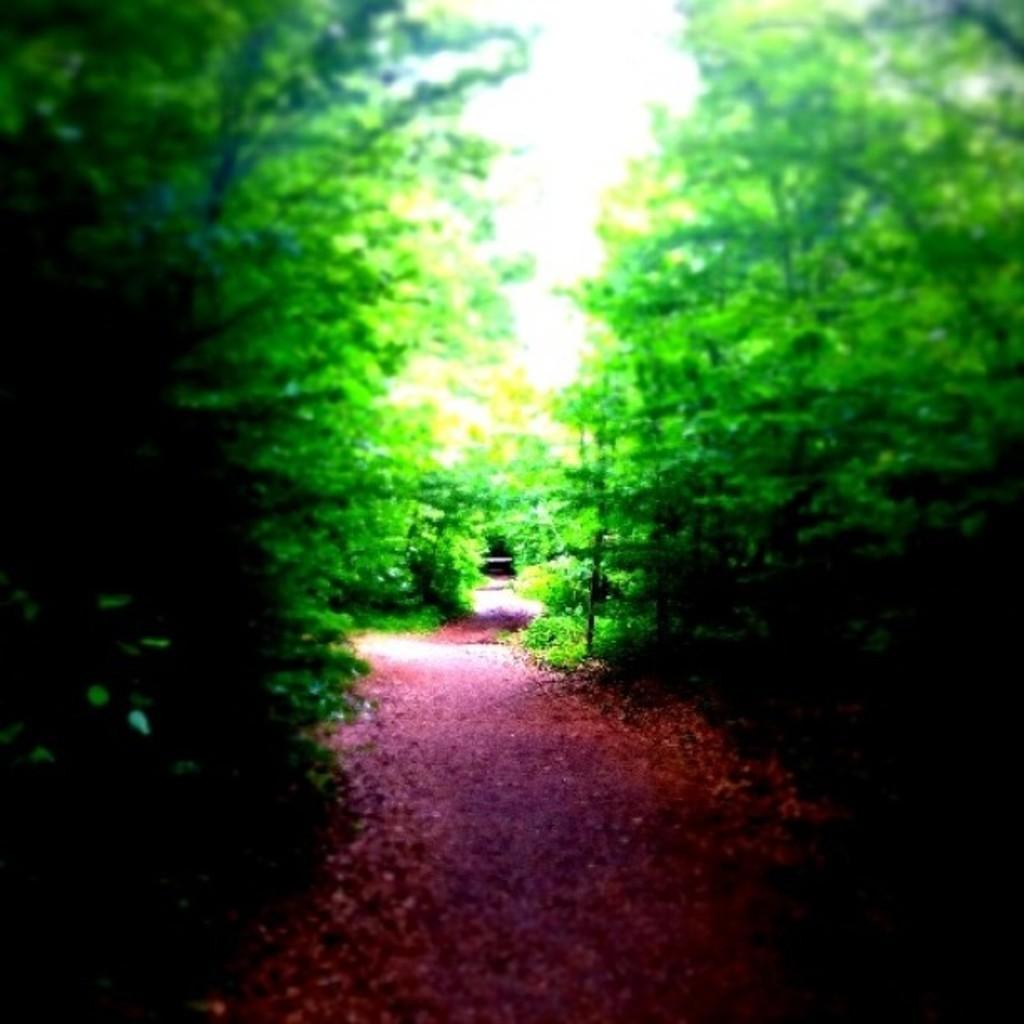Please provide a concise description of this image. In the picture I can see the trees on the left side and the right side as well. I can see the walkway in between the trees. 